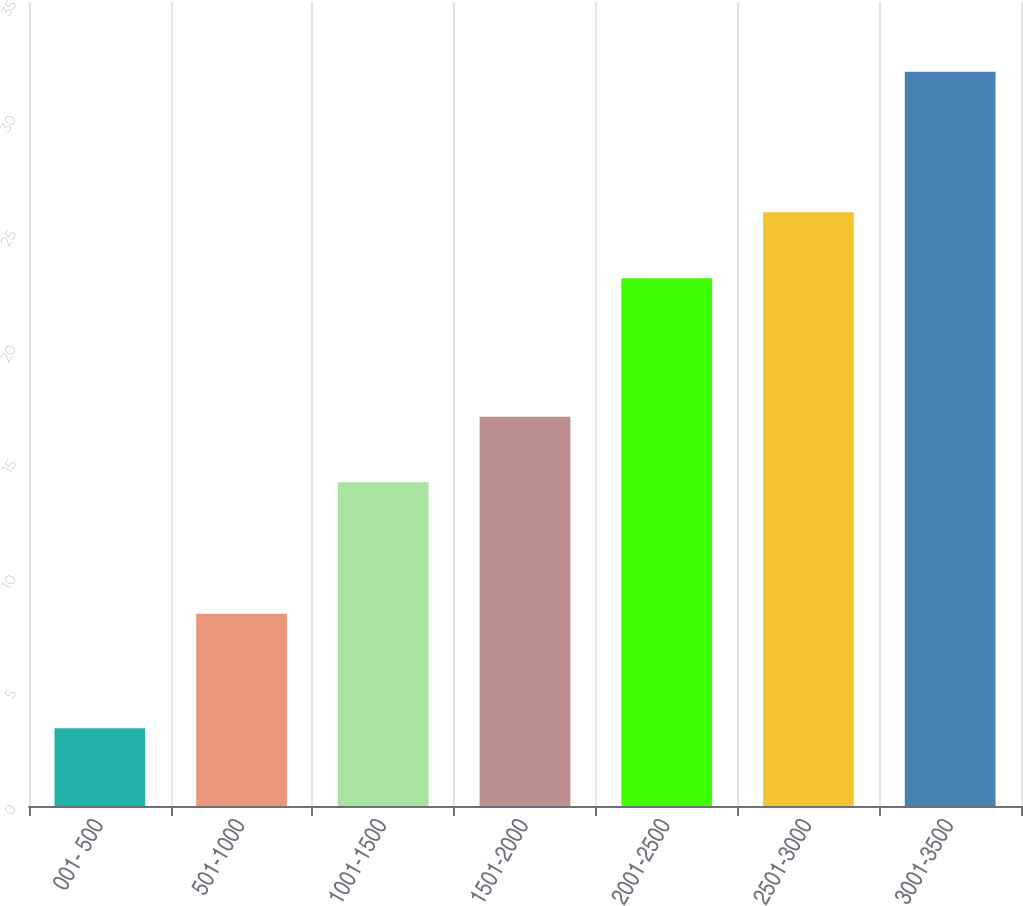Convert chart to OTSL. <chart><loc_0><loc_0><loc_500><loc_500><bar_chart><fcel>001- 500<fcel>501-1000<fcel>1001-1500<fcel>1501-2000<fcel>2001-2500<fcel>2501-3000<fcel>3001-3500<nl><fcel>3.38<fcel>8.37<fcel>14.09<fcel>16.95<fcel>22.97<fcel>25.85<fcel>31.96<nl></chart> 